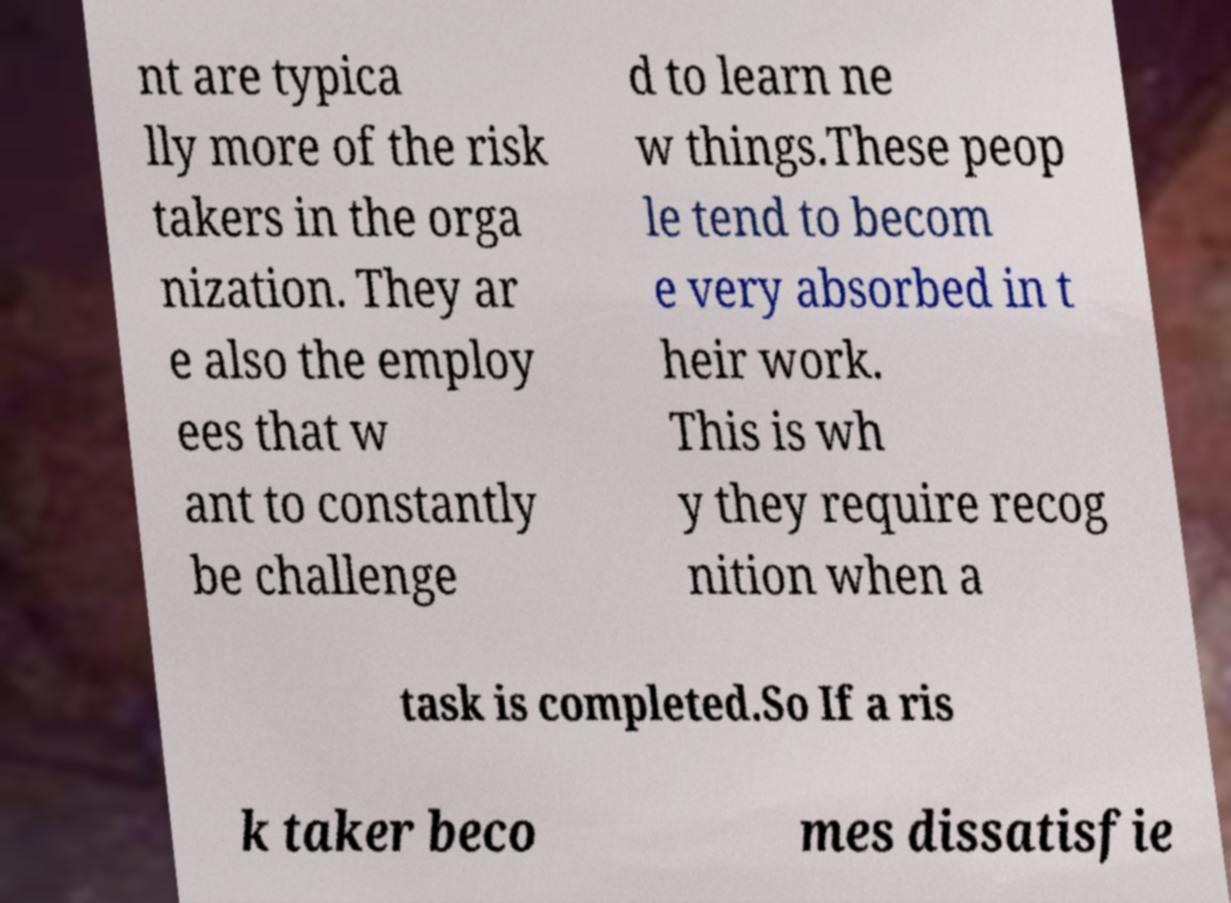Please identify and transcribe the text found in this image. nt are typica lly more of the risk takers in the orga nization. They ar e also the employ ees that w ant to constantly be challenge d to learn ne w things.These peop le tend to becom e very absorbed in t heir work. This is wh y they require recog nition when a task is completed.So If a ris k taker beco mes dissatisfie 